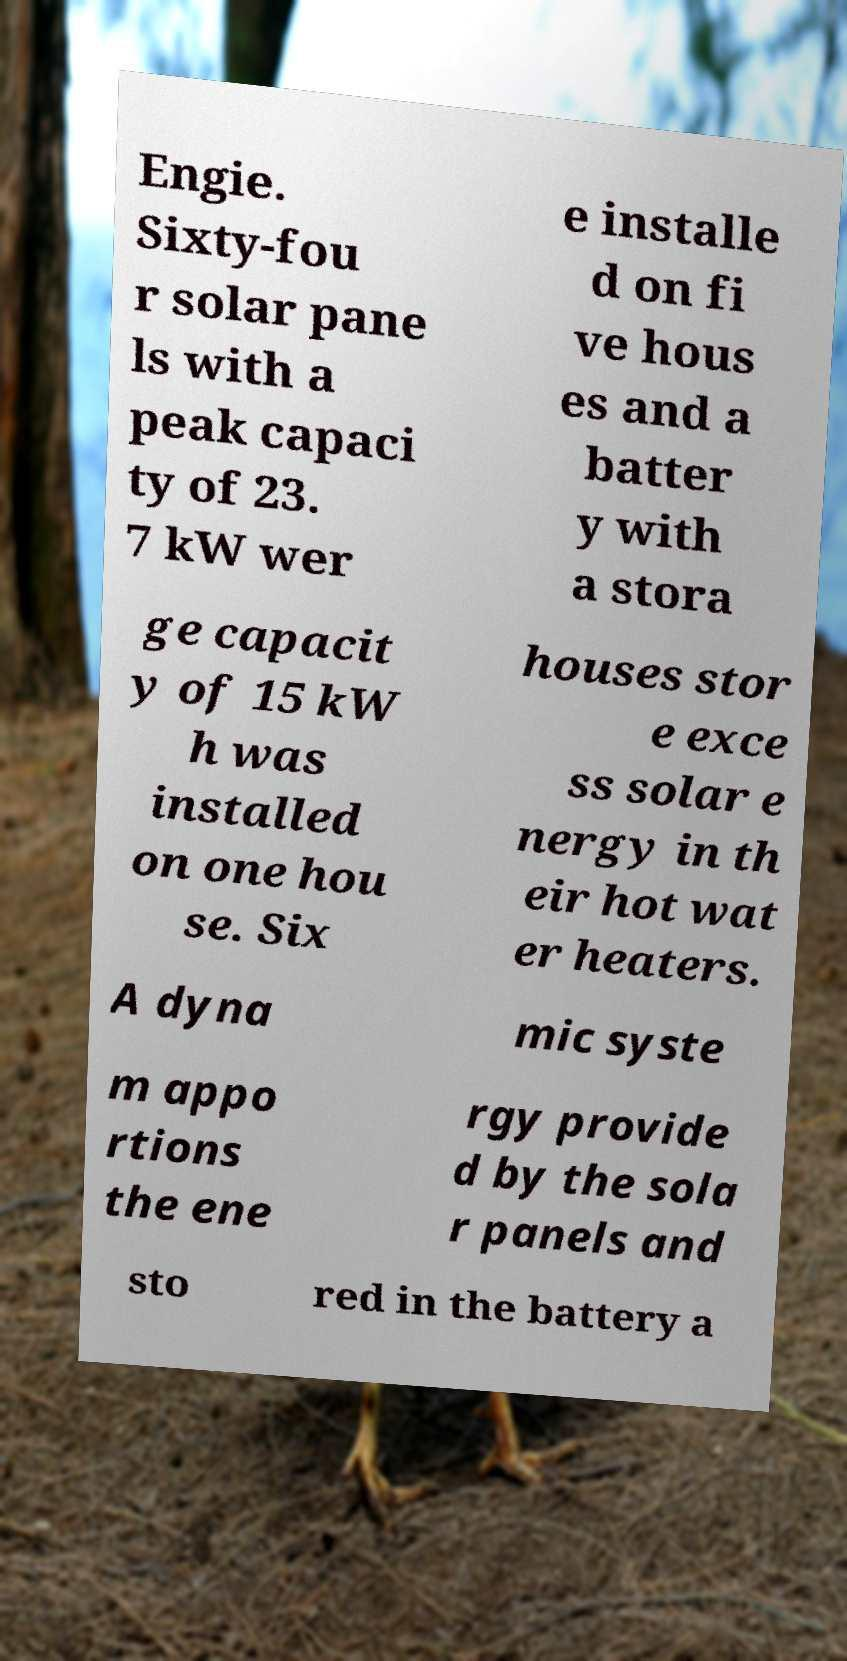Could you assist in decoding the text presented in this image and type it out clearly? Engie. Sixty-fou r solar pane ls with a peak capaci ty of 23. 7 kW wer e installe d on fi ve hous es and a batter y with a stora ge capacit y of 15 kW h was installed on one hou se. Six houses stor e exce ss solar e nergy in th eir hot wat er heaters. A dyna mic syste m appo rtions the ene rgy provide d by the sola r panels and sto red in the battery a 